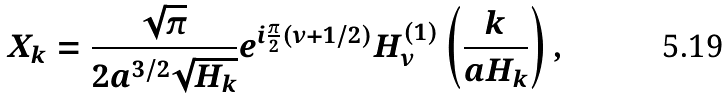<formula> <loc_0><loc_0><loc_500><loc_500>X _ { k } = \frac { \sqrt { \pi } } { 2 a ^ { 3 / 2 } \sqrt { H _ { k } } } e ^ { i \frac { \pi } { 2 } ( \nu + 1 / 2 ) } H _ { \nu } ^ { ( 1 ) } \left ( \frac { k } { a H _ { k } } \right ) ,</formula> 